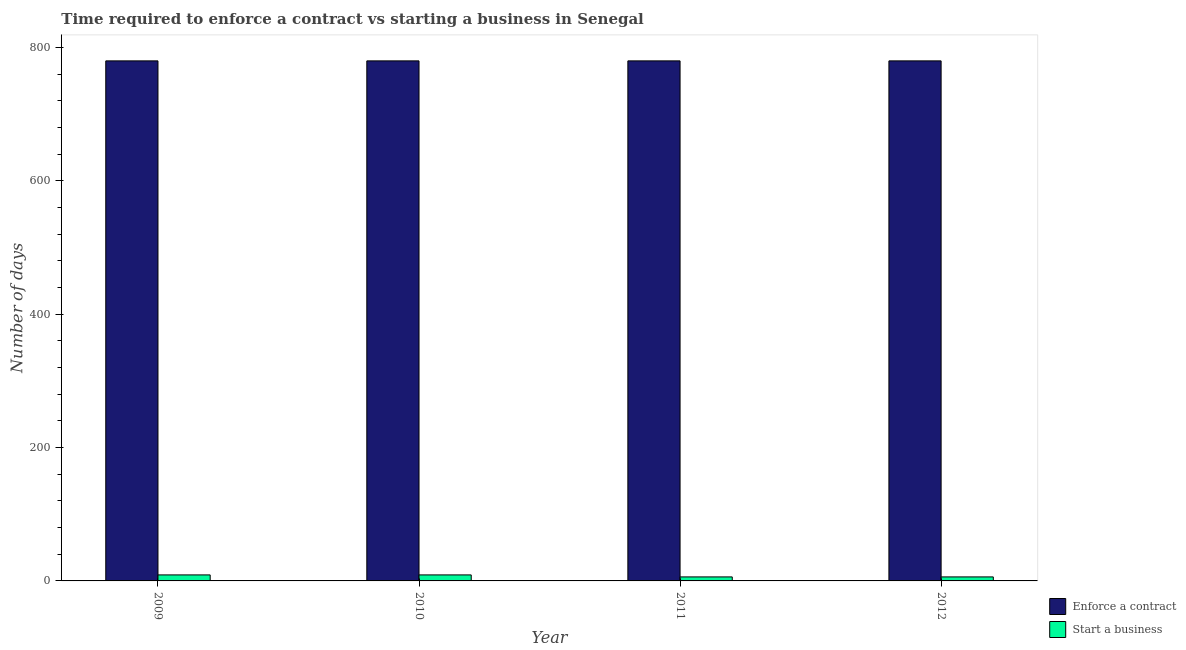How many different coloured bars are there?
Ensure brevity in your answer.  2. Are the number of bars on each tick of the X-axis equal?
Give a very brief answer. Yes. How many bars are there on the 2nd tick from the right?
Provide a short and direct response. 2. What is the label of the 4th group of bars from the left?
Offer a terse response. 2012. What is the number of days to enforece a contract in 2009?
Give a very brief answer. 780. Across all years, what is the maximum number of days to start a business?
Your response must be concise. 9. In which year was the number of days to enforece a contract maximum?
Your answer should be compact. 2009. What is the total number of days to start a business in the graph?
Offer a very short reply. 30. What is the difference between the number of days to start a business in 2009 and that in 2011?
Give a very brief answer. 3. What is the difference between the number of days to enforece a contract in 2009 and the number of days to start a business in 2012?
Ensure brevity in your answer.  0. What is the average number of days to enforece a contract per year?
Keep it short and to the point. 780. What is the ratio of the number of days to start a business in 2009 to that in 2010?
Give a very brief answer. 1. Is the number of days to enforece a contract in 2010 less than that in 2011?
Offer a terse response. No. Is the difference between the number of days to start a business in 2010 and 2012 greater than the difference between the number of days to enforece a contract in 2010 and 2012?
Give a very brief answer. No. What is the difference between the highest and the lowest number of days to enforece a contract?
Offer a very short reply. 0. What does the 2nd bar from the left in 2012 represents?
Your answer should be very brief. Start a business. What does the 2nd bar from the right in 2010 represents?
Offer a very short reply. Enforce a contract. How many bars are there?
Your answer should be compact. 8. What is the difference between two consecutive major ticks on the Y-axis?
Your answer should be very brief. 200. Does the graph contain any zero values?
Your answer should be very brief. No. Does the graph contain grids?
Provide a short and direct response. No. Where does the legend appear in the graph?
Your response must be concise. Bottom right. How many legend labels are there?
Provide a short and direct response. 2. How are the legend labels stacked?
Keep it short and to the point. Vertical. What is the title of the graph?
Make the answer very short. Time required to enforce a contract vs starting a business in Senegal. What is the label or title of the Y-axis?
Offer a very short reply. Number of days. What is the Number of days of Enforce a contract in 2009?
Keep it short and to the point. 780. What is the Number of days in Enforce a contract in 2010?
Keep it short and to the point. 780. What is the Number of days of Enforce a contract in 2011?
Provide a succinct answer. 780. What is the Number of days in Enforce a contract in 2012?
Your answer should be compact. 780. What is the Number of days of Start a business in 2012?
Offer a terse response. 6. Across all years, what is the maximum Number of days of Enforce a contract?
Your answer should be very brief. 780. Across all years, what is the maximum Number of days of Start a business?
Ensure brevity in your answer.  9. Across all years, what is the minimum Number of days in Enforce a contract?
Offer a very short reply. 780. What is the total Number of days of Enforce a contract in the graph?
Give a very brief answer. 3120. What is the difference between the Number of days in Enforce a contract in 2009 and that in 2010?
Provide a short and direct response. 0. What is the difference between the Number of days of Enforce a contract in 2010 and that in 2011?
Offer a terse response. 0. What is the difference between the Number of days in Start a business in 2010 and that in 2011?
Offer a terse response. 3. What is the difference between the Number of days in Enforce a contract in 2011 and that in 2012?
Your answer should be compact. 0. What is the difference between the Number of days of Enforce a contract in 2009 and the Number of days of Start a business in 2010?
Provide a short and direct response. 771. What is the difference between the Number of days of Enforce a contract in 2009 and the Number of days of Start a business in 2011?
Ensure brevity in your answer.  774. What is the difference between the Number of days of Enforce a contract in 2009 and the Number of days of Start a business in 2012?
Provide a short and direct response. 774. What is the difference between the Number of days in Enforce a contract in 2010 and the Number of days in Start a business in 2011?
Your answer should be very brief. 774. What is the difference between the Number of days of Enforce a contract in 2010 and the Number of days of Start a business in 2012?
Offer a terse response. 774. What is the difference between the Number of days in Enforce a contract in 2011 and the Number of days in Start a business in 2012?
Provide a succinct answer. 774. What is the average Number of days of Enforce a contract per year?
Your response must be concise. 780. What is the average Number of days of Start a business per year?
Offer a terse response. 7.5. In the year 2009, what is the difference between the Number of days of Enforce a contract and Number of days of Start a business?
Keep it short and to the point. 771. In the year 2010, what is the difference between the Number of days in Enforce a contract and Number of days in Start a business?
Your answer should be very brief. 771. In the year 2011, what is the difference between the Number of days in Enforce a contract and Number of days in Start a business?
Offer a terse response. 774. In the year 2012, what is the difference between the Number of days of Enforce a contract and Number of days of Start a business?
Provide a short and direct response. 774. What is the ratio of the Number of days of Enforce a contract in 2009 to that in 2011?
Provide a succinct answer. 1. What is the ratio of the Number of days in Enforce a contract in 2010 to that in 2012?
Keep it short and to the point. 1. What is the ratio of the Number of days in Enforce a contract in 2011 to that in 2012?
Offer a terse response. 1. What is the difference between the highest and the second highest Number of days of Enforce a contract?
Provide a succinct answer. 0. 